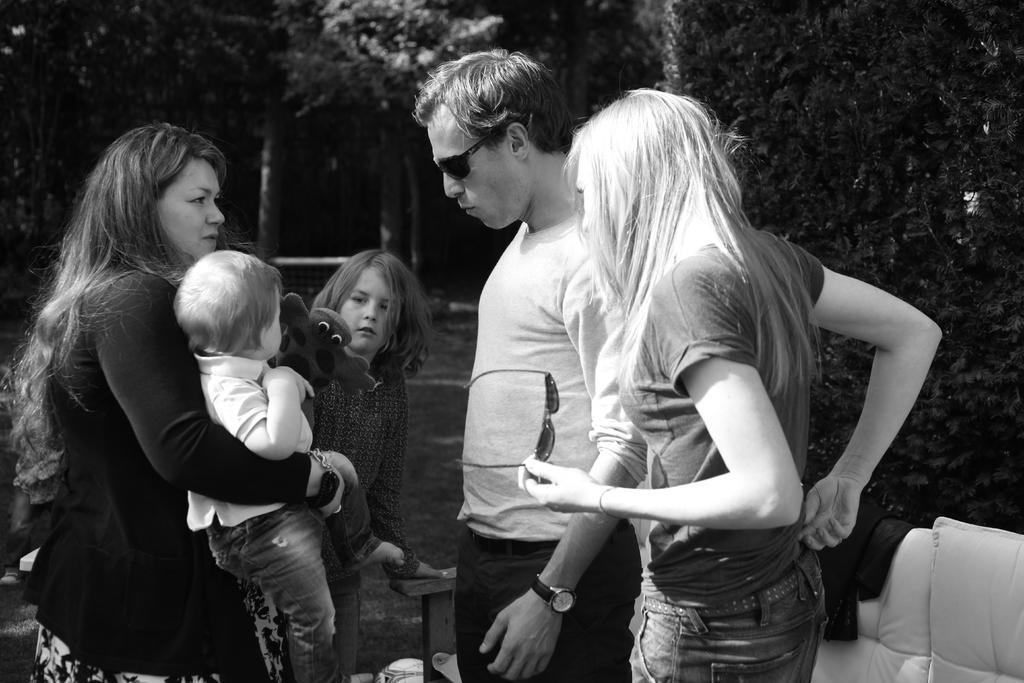Please provide a concise description of this image. Black and white picture. Here we can see people. This woman is holding goggles. Another woman is holding a baby. In-front of this baby there is a toy. On this couch there is a jacket. Background we can see trees. 